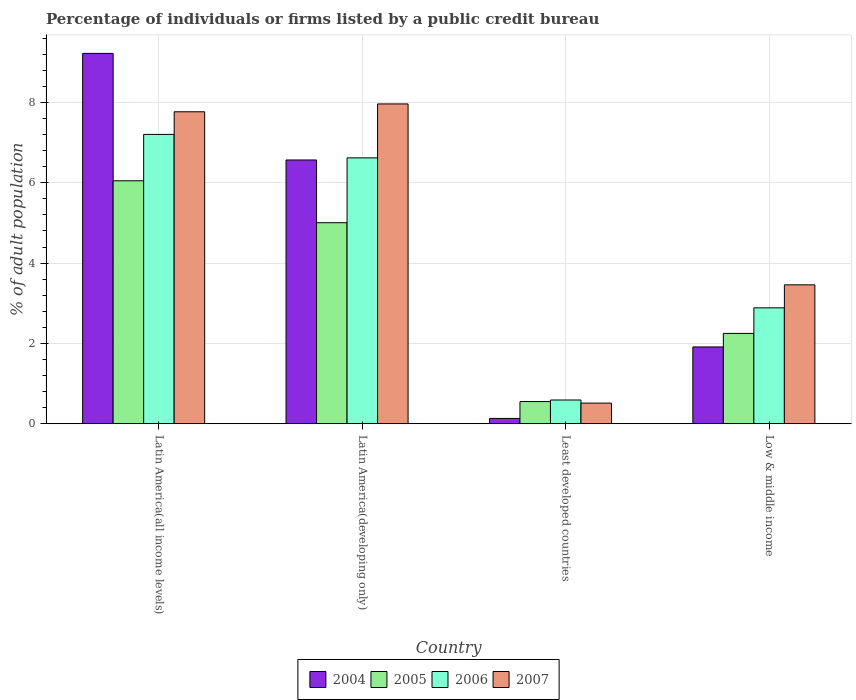How many bars are there on the 1st tick from the right?
Your answer should be very brief. 4. What is the label of the 1st group of bars from the left?
Provide a succinct answer. Latin America(all income levels). In how many cases, is the number of bars for a given country not equal to the number of legend labels?
Offer a terse response. 0. What is the percentage of population listed by a public credit bureau in 2004 in Latin America(all income levels)?
Your answer should be very brief. 9.22. Across all countries, what is the maximum percentage of population listed by a public credit bureau in 2004?
Keep it short and to the point. 9.22. Across all countries, what is the minimum percentage of population listed by a public credit bureau in 2006?
Keep it short and to the point. 0.59. In which country was the percentage of population listed by a public credit bureau in 2007 maximum?
Make the answer very short. Latin America(developing only). In which country was the percentage of population listed by a public credit bureau in 2005 minimum?
Provide a short and direct response. Least developed countries. What is the total percentage of population listed by a public credit bureau in 2005 in the graph?
Provide a succinct answer. 13.85. What is the difference between the percentage of population listed by a public credit bureau in 2005 in Latin America(all income levels) and that in Low & middle income?
Give a very brief answer. 3.8. What is the difference between the percentage of population listed by a public credit bureau in 2005 in Latin America(developing only) and the percentage of population listed by a public credit bureau in 2004 in Least developed countries?
Your answer should be very brief. 4.87. What is the average percentage of population listed by a public credit bureau in 2005 per country?
Your answer should be very brief. 3.46. What is the difference between the percentage of population listed by a public credit bureau of/in 2004 and percentage of population listed by a public credit bureau of/in 2006 in Latin America(developing only)?
Offer a terse response. -0.05. In how many countries, is the percentage of population listed by a public credit bureau in 2004 greater than 3.6 %?
Your answer should be very brief. 2. What is the ratio of the percentage of population listed by a public credit bureau in 2004 in Latin America(all income levels) to that in Low & middle income?
Give a very brief answer. 4.82. Is the difference between the percentage of population listed by a public credit bureau in 2004 in Latin America(developing only) and Least developed countries greater than the difference between the percentage of population listed by a public credit bureau in 2006 in Latin America(developing only) and Least developed countries?
Offer a very short reply. Yes. What is the difference between the highest and the second highest percentage of population listed by a public credit bureau in 2005?
Your answer should be very brief. -2.76. What is the difference between the highest and the lowest percentage of population listed by a public credit bureau in 2007?
Offer a very short reply. 7.45. Is the sum of the percentage of population listed by a public credit bureau in 2005 in Latin America(developing only) and Low & middle income greater than the maximum percentage of population listed by a public credit bureau in 2004 across all countries?
Give a very brief answer. No. Is it the case that in every country, the sum of the percentage of population listed by a public credit bureau in 2005 and percentage of population listed by a public credit bureau in 2007 is greater than the sum of percentage of population listed by a public credit bureau in 2006 and percentage of population listed by a public credit bureau in 2004?
Provide a short and direct response. No. What does the 3rd bar from the left in Low & middle income represents?
Give a very brief answer. 2006. Is it the case that in every country, the sum of the percentage of population listed by a public credit bureau in 2004 and percentage of population listed by a public credit bureau in 2007 is greater than the percentage of population listed by a public credit bureau in 2006?
Provide a succinct answer. Yes. Where does the legend appear in the graph?
Your answer should be compact. Bottom center. How many legend labels are there?
Give a very brief answer. 4. What is the title of the graph?
Offer a very short reply. Percentage of individuals or firms listed by a public credit bureau. What is the label or title of the Y-axis?
Keep it short and to the point. % of adult population. What is the % of adult population of 2004 in Latin America(all income levels)?
Your answer should be compact. 9.22. What is the % of adult population of 2005 in Latin America(all income levels)?
Give a very brief answer. 6.05. What is the % of adult population in 2006 in Latin America(all income levels)?
Your answer should be very brief. 7.2. What is the % of adult population in 2007 in Latin America(all income levels)?
Your answer should be compact. 7.77. What is the % of adult population of 2004 in Latin America(developing only)?
Provide a short and direct response. 6.57. What is the % of adult population of 2005 in Latin America(developing only)?
Your answer should be compact. 5. What is the % of adult population of 2006 in Latin America(developing only)?
Provide a short and direct response. 6.62. What is the % of adult population of 2007 in Latin America(developing only)?
Provide a succinct answer. 7.96. What is the % of adult population of 2004 in Least developed countries?
Your answer should be very brief. 0.13. What is the % of adult population of 2005 in Least developed countries?
Your answer should be compact. 0.55. What is the % of adult population of 2006 in Least developed countries?
Keep it short and to the point. 0.59. What is the % of adult population in 2007 in Least developed countries?
Ensure brevity in your answer.  0.51. What is the % of adult population of 2004 in Low & middle income?
Make the answer very short. 1.91. What is the % of adult population in 2005 in Low & middle income?
Your response must be concise. 2.25. What is the % of adult population of 2006 in Low & middle income?
Keep it short and to the point. 2.89. What is the % of adult population of 2007 in Low & middle income?
Provide a succinct answer. 3.46. Across all countries, what is the maximum % of adult population of 2004?
Your response must be concise. 9.22. Across all countries, what is the maximum % of adult population in 2005?
Your answer should be compact. 6.05. Across all countries, what is the maximum % of adult population of 2006?
Your answer should be compact. 7.2. Across all countries, what is the maximum % of adult population of 2007?
Ensure brevity in your answer.  7.96. Across all countries, what is the minimum % of adult population in 2004?
Offer a terse response. 0.13. Across all countries, what is the minimum % of adult population in 2005?
Provide a short and direct response. 0.55. Across all countries, what is the minimum % of adult population in 2006?
Your response must be concise. 0.59. Across all countries, what is the minimum % of adult population in 2007?
Ensure brevity in your answer.  0.51. What is the total % of adult population in 2004 in the graph?
Your answer should be very brief. 17.83. What is the total % of adult population of 2005 in the graph?
Your answer should be compact. 13.85. What is the total % of adult population of 2006 in the graph?
Offer a very short reply. 17.3. What is the total % of adult population in 2007 in the graph?
Offer a terse response. 19.7. What is the difference between the % of adult population of 2004 in Latin America(all income levels) and that in Latin America(developing only)?
Your answer should be compact. 2.65. What is the difference between the % of adult population of 2005 in Latin America(all income levels) and that in Latin America(developing only)?
Provide a succinct answer. 1.04. What is the difference between the % of adult population of 2006 in Latin America(all income levels) and that in Latin America(developing only)?
Give a very brief answer. 0.58. What is the difference between the % of adult population of 2007 in Latin America(all income levels) and that in Latin America(developing only)?
Ensure brevity in your answer.  -0.2. What is the difference between the % of adult population in 2004 in Latin America(all income levels) and that in Least developed countries?
Offer a very short reply. 9.09. What is the difference between the % of adult population in 2005 in Latin America(all income levels) and that in Least developed countries?
Offer a very short reply. 5.5. What is the difference between the % of adult population in 2006 in Latin America(all income levels) and that in Least developed countries?
Make the answer very short. 6.61. What is the difference between the % of adult population in 2007 in Latin America(all income levels) and that in Least developed countries?
Give a very brief answer. 7.25. What is the difference between the % of adult population of 2004 in Latin America(all income levels) and that in Low & middle income?
Provide a short and direct response. 7.31. What is the difference between the % of adult population in 2005 in Latin America(all income levels) and that in Low & middle income?
Give a very brief answer. 3.8. What is the difference between the % of adult population of 2006 in Latin America(all income levels) and that in Low & middle income?
Ensure brevity in your answer.  4.32. What is the difference between the % of adult population of 2007 in Latin America(all income levels) and that in Low & middle income?
Give a very brief answer. 4.31. What is the difference between the % of adult population in 2004 in Latin America(developing only) and that in Least developed countries?
Keep it short and to the point. 6.43. What is the difference between the % of adult population of 2005 in Latin America(developing only) and that in Least developed countries?
Provide a short and direct response. 4.45. What is the difference between the % of adult population in 2006 in Latin America(developing only) and that in Least developed countries?
Your answer should be compact. 6.03. What is the difference between the % of adult population in 2007 in Latin America(developing only) and that in Least developed countries?
Keep it short and to the point. 7.45. What is the difference between the % of adult population in 2004 in Latin America(developing only) and that in Low & middle income?
Offer a very short reply. 4.65. What is the difference between the % of adult population in 2005 in Latin America(developing only) and that in Low & middle income?
Keep it short and to the point. 2.76. What is the difference between the % of adult population in 2006 in Latin America(developing only) and that in Low & middle income?
Make the answer very short. 3.73. What is the difference between the % of adult population of 2007 in Latin America(developing only) and that in Low & middle income?
Keep it short and to the point. 4.5. What is the difference between the % of adult population in 2004 in Least developed countries and that in Low & middle income?
Ensure brevity in your answer.  -1.78. What is the difference between the % of adult population in 2005 in Least developed countries and that in Low & middle income?
Your answer should be compact. -1.7. What is the difference between the % of adult population in 2006 in Least developed countries and that in Low & middle income?
Make the answer very short. -2.29. What is the difference between the % of adult population in 2007 in Least developed countries and that in Low & middle income?
Provide a short and direct response. -2.94. What is the difference between the % of adult population in 2004 in Latin America(all income levels) and the % of adult population in 2005 in Latin America(developing only)?
Provide a succinct answer. 4.22. What is the difference between the % of adult population in 2004 in Latin America(all income levels) and the % of adult population in 2006 in Latin America(developing only)?
Offer a terse response. 2.6. What is the difference between the % of adult population of 2004 in Latin America(all income levels) and the % of adult population of 2007 in Latin America(developing only)?
Give a very brief answer. 1.26. What is the difference between the % of adult population of 2005 in Latin America(all income levels) and the % of adult population of 2006 in Latin America(developing only)?
Your answer should be very brief. -0.57. What is the difference between the % of adult population in 2005 in Latin America(all income levels) and the % of adult population in 2007 in Latin America(developing only)?
Provide a succinct answer. -1.91. What is the difference between the % of adult population of 2006 in Latin America(all income levels) and the % of adult population of 2007 in Latin America(developing only)?
Provide a succinct answer. -0.76. What is the difference between the % of adult population in 2004 in Latin America(all income levels) and the % of adult population in 2005 in Least developed countries?
Your answer should be compact. 8.67. What is the difference between the % of adult population in 2004 in Latin America(all income levels) and the % of adult population in 2006 in Least developed countries?
Offer a very short reply. 8.63. What is the difference between the % of adult population of 2004 in Latin America(all income levels) and the % of adult population of 2007 in Least developed countries?
Keep it short and to the point. 8.71. What is the difference between the % of adult population of 2005 in Latin America(all income levels) and the % of adult population of 2006 in Least developed countries?
Your answer should be compact. 5.46. What is the difference between the % of adult population of 2005 in Latin America(all income levels) and the % of adult population of 2007 in Least developed countries?
Your answer should be compact. 5.53. What is the difference between the % of adult population in 2006 in Latin America(all income levels) and the % of adult population in 2007 in Least developed countries?
Provide a short and direct response. 6.69. What is the difference between the % of adult population of 2004 in Latin America(all income levels) and the % of adult population of 2005 in Low & middle income?
Provide a succinct answer. 6.97. What is the difference between the % of adult population of 2004 in Latin America(all income levels) and the % of adult population of 2006 in Low & middle income?
Keep it short and to the point. 6.33. What is the difference between the % of adult population in 2004 in Latin America(all income levels) and the % of adult population in 2007 in Low & middle income?
Your response must be concise. 5.76. What is the difference between the % of adult population in 2005 in Latin America(all income levels) and the % of adult population in 2006 in Low & middle income?
Give a very brief answer. 3.16. What is the difference between the % of adult population in 2005 in Latin America(all income levels) and the % of adult population in 2007 in Low & middle income?
Provide a succinct answer. 2.59. What is the difference between the % of adult population of 2006 in Latin America(all income levels) and the % of adult population of 2007 in Low & middle income?
Your answer should be compact. 3.75. What is the difference between the % of adult population of 2004 in Latin America(developing only) and the % of adult population of 2005 in Least developed countries?
Provide a succinct answer. 6.01. What is the difference between the % of adult population of 2004 in Latin America(developing only) and the % of adult population of 2006 in Least developed countries?
Keep it short and to the point. 5.98. What is the difference between the % of adult population in 2004 in Latin America(developing only) and the % of adult population in 2007 in Least developed countries?
Ensure brevity in your answer.  6.05. What is the difference between the % of adult population in 2005 in Latin America(developing only) and the % of adult population in 2006 in Least developed countries?
Keep it short and to the point. 4.41. What is the difference between the % of adult population in 2005 in Latin America(developing only) and the % of adult population in 2007 in Least developed countries?
Your response must be concise. 4.49. What is the difference between the % of adult population of 2006 in Latin America(developing only) and the % of adult population of 2007 in Least developed countries?
Provide a short and direct response. 6.11. What is the difference between the % of adult population in 2004 in Latin America(developing only) and the % of adult population in 2005 in Low & middle income?
Keep it short and to the point. 4.32. What is the difference between the % of adult population in 2004 in Latin America(developing only) and the % of adult population in 2006 in Low & middle income?
Give a very brief answer. 3.68. What is the difference between the % of adult population of 2004 in Latin America(developing only) and the % of adult population of 2007 in Low & middle income?
Keep it short and to the point. 3.11. What is the difference between the % of adult population in 2005 in Latin America(developing only) and the % of adult population in 2006 in Low & middle income?
Ensure brevity in your answer.  2.12. What is the difference between the % of adult population of 2005 in Latin America(developing only) and the % of adult population of 2007 in Low & middle income?
Your answer should be compact. 1.55. What is the difference between the % of adult population in 2006 in Latin America(developing only) and the % of adult population in 2007 in Low & middle income?
Your answer should be compact. 3.16. What is the difference between the % of adult population in 2004 in Least developed countries and the % of adult population in 2005 in Low & middle income?
Offer a terse response. -2.12. What is the difference between the % of adult population of 2004 in Least developed countries and the % of adult population of 2006 in Low & middle income?
Your answer should be compact. -2.75. What is the difference between the % of adult population in 2004 in Least developed countries and the % of adult population in 2007 in Low & middle income?
Provide a short and direct response. -3.33. What is the difference between the % of adult population in 2005 in Least developed countries and the % of adult population in 2006 in Low & middle income?
Make the answer very short. -2.33. What is the difference between the % of adult population in 2005 in Least developed countries and the % of adult population in 2007 in Low & middle income?
Offer a terse response. -2.91. What is the difference between the % of adult population in 2006 in Least developed countries and the % of adult population in 2007 in Low & middle income?
Ensure brevity in your answer.  -2.87. What is the average % of adult population of 2004 per country?
Offer a terse response. 4.46. What is the average % of adult population in 2005 per country?
Make the answer very short. 3.46. What is the average % of adult population of 2006 per country?
Keep it short and to the point. 4.32. What is the average % of adult population in 2007 per country?
Ensure brevity in your answer.  4.93. What is the difference between the % of adult population of 2004 and % of adult population of 2005 in Latin America(all income levels)?
Provide a short and direct response. 3.17. What is the difference between the % of adult population in 2004 and % of adult population in 2006 in Latin America(all income levels)?
Make the answer very short. 2.02. What is the difference between the % of adult population in 2004 and % of adult population in 2007 in Latin America(all income levels)?
Your answer should be compact. 1.45. What is the difference between the % of adult population in 2005 and % of adult population in 2006 in Latin America(all income levels)?
Offer a very short reply. -1.16. What is the difference between the % of adult population in 2005 and % of adult population in 2007 in Latin America(all income levels)?
Offer a terse response. -1.72. What is the difference between the % of adult population in 2006 and % of adult population in 2007 in Latin America(all income levels)?
Ensure brevity in your answer.  -0.56. What is the difference between the % of adult population of 2004 and % of adult population of 2005 in Latin America(developing only)?
Your response must be concise. 1.56. What is the difference between the % of adult population in 2004 and % of adult population in 2006 in Latin America(developing only)?
Provide a succinct answer. -0.05. What is the difference between the % of adult population in 2004 and % of adult population in 2007 in Latin America(developing only)?
Your answer should be very brief. -1.4. What is the difference between the % of adult population of 2005 and % of adult population of 2006 in Latin America(developing only)?
Give a very brief answer. -1.61. What is the difference between the % of adult population in 2005 and % of adult population in 2007 in Latin America(developing only)?
Your answer should be compact. -2.96. What is the difference between the % of adult population of 2006 and % of adult population of 2007 in Latin America(developing only)?
Offer a very short reply. -1.34. What is the difference between the % of adult population in 2004 and % of adult population in 2005 in Least developed countries?
Your answer should be compact. -0.42. What is the difference between the % of adult population in 2004 and % of adult population in 2006 in Least developed countries?
Provide a succinct answer. -0.46. What is the difference between the % of adult population in 2004 and % of adult population in 2007 in Least developed countries?
Your response must be concise. -0.38. What is the difference between the % of adult population of 2005 and % of adult population of 2006 in Least developed countries?
Your answer should be compact. -0.04. What is the difference between the % of adult population of 2005 and % of adult population of 2007 in Least developed countries?
Keep it short and to the point. 0.04. What is the difference between the % of adult population in 2006 and % of adult population in 2007 in Least developed countries?
Provide a short and direct response. 0.08. What is the difference between the % of adult population in 2004 and % of adult population in 2005 in Low & middle income?
Provide a short and direct response. -0.34. What is the difference between the % of adult population of 2004 and % of adult population of 2006 in Low & middle income?
Give a very brief answer. -0.97. What is the difference between the % of adult population in 2004 and % of adult population in 2007 in Low & middle income?
Offer a very short reply. -1.55. What is the difference between the % of adult population of 2005 and % of adult population of 2006 in Low & middle income?
Keep it short and to the point. -0.64. What is the difference between the % of adult population in 2005 and % of adult population in 2007 in Low & middle income?
Keep it short and to the point. -1.21. What is the difference between the % of adult population in 2006 and % of adult population in 2007 in Low & middle income?
Provide a short and direct response. -0.57. What is the ratio of the % of adult population in 2004 in Latin America(all income levels) to that in Latin America(developing only)?
Your response must be concise. 1.4. What is the ratio of the % of adult population of 2005 in Latin America(all income levels) to that in Latin America(developing only)?
Your answer should be compact. 1.21. What is the ratio of the % of adult population of 2006 in Latin America(all income levels) to that in Latin America(developing only)?
Provide a succinct answer. 1.09. What is the ratio of the % of adult population of 2007 in Latin America(all income levels) to that in Latin America(developing only)?
Give a very brief answer. 0.98. What is the ratio of the % of adult population in 2004 in Latin America(all income levels) to that in Least developed countries?
Your response must be concise. 69.62. What is the ratio of the % of adult population in 2005 in Latin America(all income levels) to that in Least developed countries?
Provide a succinct answer. 10.95. What is the ratio of the % of adult population of 2006 in Latin America(all income levels) to that in Least developed countries?
Your response must be concise. 12.19. What is the ratio of the % of adult population of 2007 in Latin America(all income levels) to that in Least developed countries?
Your answer should be compact. 15.11. What is the ratio of the % of adult population in 2004 in Latin America(all income levels) to that in Low & middle income?
Your answer should be compact. 4.82. What is the ratio of the % of adult population in 2005 in Latin America(all income levels) to that in Low & middle income?
Your response must be concise. 2.69. What is the ratio of the % of adult population of 2006 in Latin America(all income levels) to that in Low & middle income?
Your response must be concise. 2.5. What is the ratio of the % of adult population of 2007 in Latin America(all income levels) to that in Low & middle income?
Offer a terse response. 2.25. What is the ratio of the % of adult population of 2004 in Latin America(developing only) to that in Least developed countries?
Offer a very short reply. 49.59. What is the ratio of the % of adult population of 2005 in Latin America(developing only) to that in Least developed countries?
Ensure brevity in your answer.  9.06. What is the ratio of the % of adult population in 2006 in Latin America(developing only) to that in Least developed countries?
Provide a short and direct response. 11.21. What is the ratio of the % of adult population of 2007 in Latin America(developing only) to that in Least developed countries?
Provide a succinct answer. 15.49. What is the ratio of the % of adult population in 2004 in Latin America(developing only) to that in Low & middle income?
Your answer should be compact. 3.43. What is the ratio of the % of adult population of 2005 in Latin America(developing only) to that in Low & middle income?
Your answer should be very brief. 2.23. What is the ratio of the % of adult population in 2006 in Latin America(developing only) to that in Low & middle income?
Ensure brevity in your answer.  2.29. What is the ratio of the % of adult population in 2007 in Latin America(developing only) to that in Low & middle income?
Make the answer very short. 2.3. What is the ratio of the % of adult population in 2004 in Least developed countries to that in Low & middle income?
Make the answer very short. 0.07. What is the ratio of the % of adult population of 2005 in Least developed countries to that in Low & middle income?
Your answer should be very brief. 0.25. What is the ratio of the % of adult population of 2006 in Least developed countries to that in Low & middle income?
Give a very brief answer. 0.2. What is the ratio of the % of adult population of 2007 in Least developed countries to that in Low & middle income?
Your response must be concise. 0.15. What is the difference between the highest and the second highest % of adult population of 2004?
Your response must be concise. 2.65. What is the difference between the highest and the second highest % of adult population of 2005?
Your answer should be very brief. 1.04. What is the difference between the highest and the second highest % of adult population of 2006?
Make the answer very short. 0.58. What is the difference between the highest and the second highest % of adult population in 2007?
Your response must be concise. 0.2. What is the difference between the highest and the lowest % of adult population of 2004?
Give a very brief answer. 9.09. What is the difference between the highest and the lowest % of adult population of 2005?
Make the answer very short. 5.5. What is the difference between the highest and the lowest % of adult population of 2006?
Give a very brief answer. 6.61. What is the difference between the highest and the lowest % of adult population in 2007?
Offer a very short reply. 7.45. 